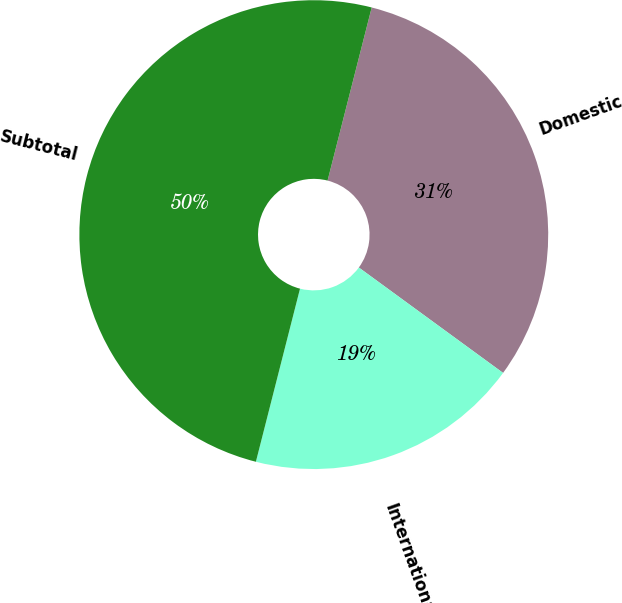Convert chart to OTSL. <chart><loc_0><loc_0><loc_500><loc_500><pie_chart><fcel>Domestic<fcel>International<fcel>Subtotal<nl><fcel>31.07%<fcel>18.93%<fcel>50.0%<nl></chart> 